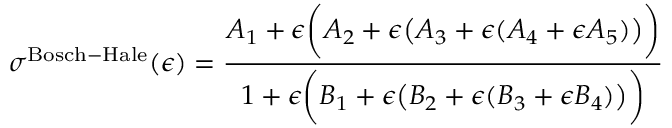<formula> <loc_0><loc_0><loc_500><loc_500>\sigma ^ { B o s c h - H a l e } ( \epsilon ) = { \frac { A _ { 1 } + \epsilon { \left ( } A _ { 2 } + \epsilon { \left ( } A _ { 3 } + \epsilon ( A _ { 4 } + \epsilon A _ { 5 } ) { \right ) } { \right ) } } { 1 + \epsilon { \left ( } B _ { 1 } + \epsilon { \left ( } B _ { 2 } + \epsilon ( B _ { 3 } + \epsilon B _ { 4 } ) { \right ) } { \right ) } } }</formula> 